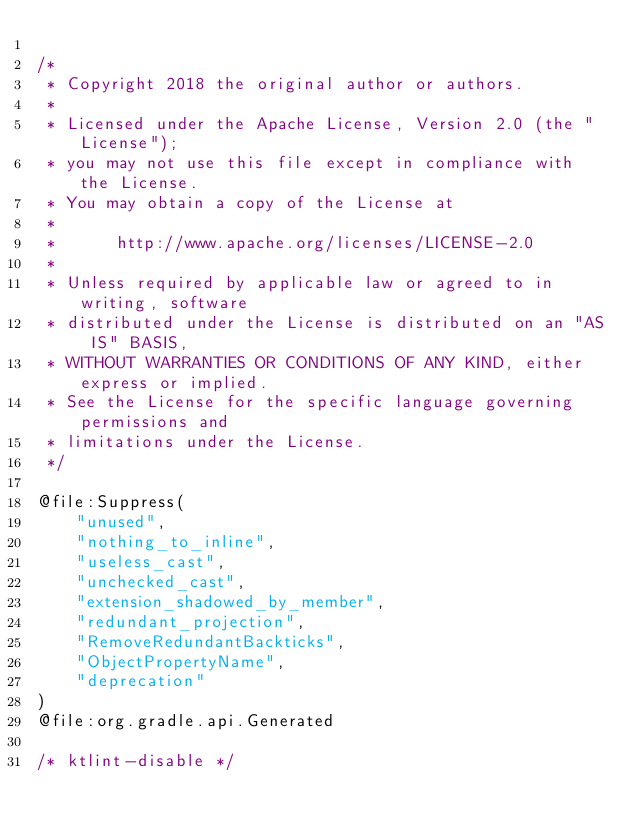<code> <loc_0><loc_0><loc_500><loc_500><_Kotlin_>
/*
 * Copyright 2018 the original author or authors.
 *
 * Licensed under the Apache License, Version 2.0 (the "License");
 * you may not use this file except in compliance with the License.
 * You may obtain a copy of the License at
 *
 *      http://www.apache.org/licenses/LICENSE-2.0
 *
 * Unless required by applicable law or agreed to in writing, software
 * distributed under the License is distributed on an "AS IS" BASIS,
 * WITHOUT WARRANTIES OR CONDITIONS OF ANY KIND, either express or implied.
 * See the License for the specific language governing permissions and
 * limitations under the License.
 */

@file:Suppress(
    "unused",
    "nothing_to_inline",
    "useless_cast",
    "unchecked_cast",
    "extension_shadowed_by_member",
    "redundant_projection",
    "RemoveRedundantBackticks",
    "ObjectPropertyName",
    "deprecation"
)
@file:org.gradle.api.Generated

/* ktlint-disable */
</code> 